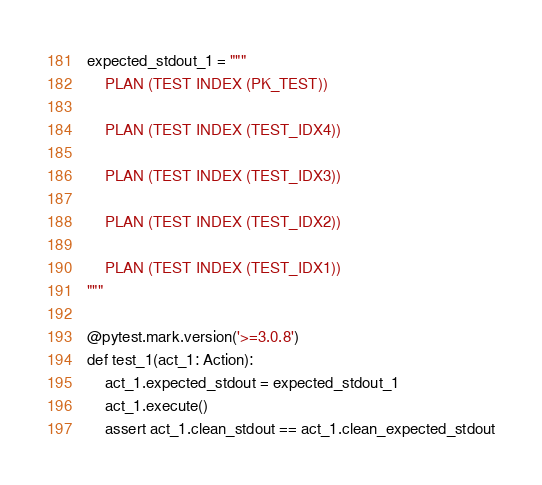Convert code to text. <code><loc_0><loc_0><loc_500><loc_500><_Python_>
expected_stdout_1 = """
    PLAN (TEST INDEX (PK_TEST))

    PLAN (TEST INDEX (TEST_IDX4))

    PLAN (TEST INDEX (TEST_IDX3))

    PLAN (TEST INDEX (TEST_IDX2))

    PLAN (TEST INDEX (TEST_IDX1))
"""

@pytest.mark.version('>=3.0.8')
def test_1(act_1: Action):
    act_1.expected_stdout = expected_stdout_1
    act_1.execute()
    assert act_1.clean_stdout == act_1.clean_expected_stdout

</code> 